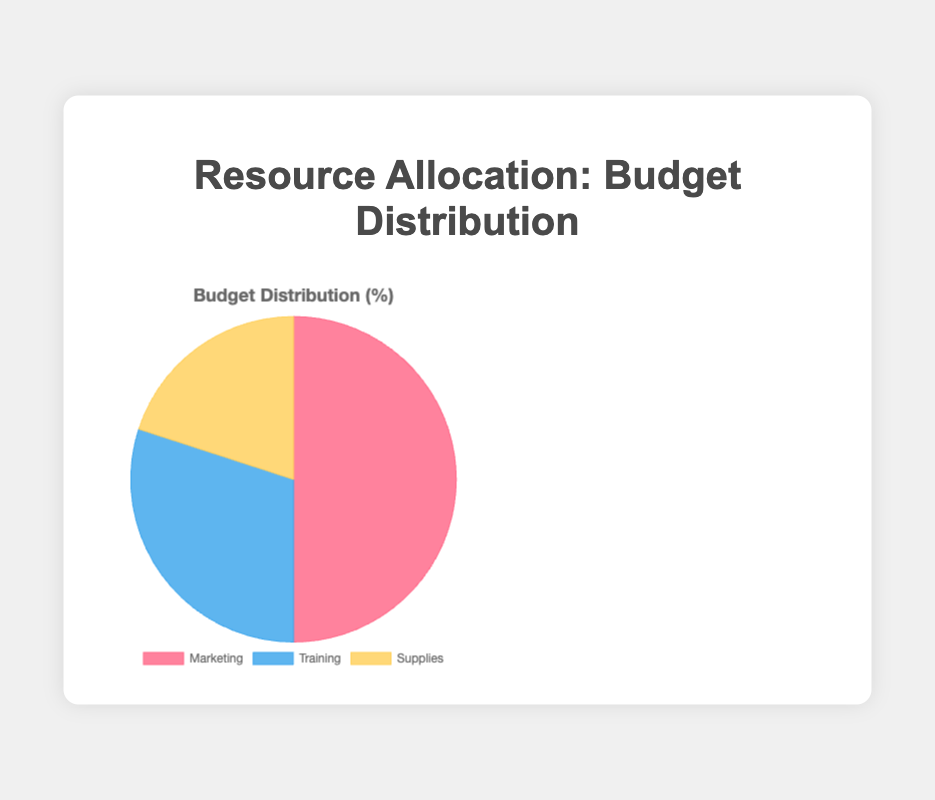What percentage of the budget is allocated to Marketing? The pie chart shows that the percentage of the budget allocated to Marketing is directly labeled as 50%.
Answer: 50% What is the difference in budget allocation between Training and Supplies? The pie chart shows Training has 30% and Supplies have 20%. The difference is calculated as 30% - 20% = 10%.
Answer: 10% Which resource has the smallest budget allocation? The pie chart labels indicate that Supplies is allocated 20%, which is the smallest percentage among the three categories.
Answer: Supplies By how much does the budget allocation for Marketing exceed the combined budget allocation for Training and Supplies? Marketing has 50%, Training has 30%, and Supplies have 20%. The combined budget for Training and Supplies is 30% + 20% = 50%. The difference is 50% - 50% = 0%.
Answer: 0% What color represents the Training budget in the pie chart? The pie chart uses blue to represent the Training budget. This can be observed by matching the colors and labels on the chart.
Answer: Blue If the Supplies budget was increased by 10%, what would the new percentage be? Initial Supplies budget is 20%. An increase of 10% would be calculated as 20% + 10% = 30%.
Answer: 30% How does the combined budget for Social Media and Content Marketing within the Marketing category compare to the Training budget? Within Marketing, Social Media has 20% and Content Marketing has 15%. Combined, they account for 20% + 15% = 35%. The Training budget is 30%.
Answer: 35% vs 30% Which category, Marketing or Training, has a larger budget, and by how much? The pie chart shows that Marketing has 50% and Training has 30%. The difference is 50% - 30% = 20%.
Answer: Marketing by 20% What is the least prominent sector of the pie chart in terms of color representation? The least prominent sector, visually the smallest, is represented by the Supplies category, which is yellow.
Answer: Yellow 